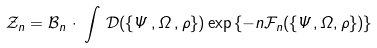<formula> <loc_0><loc_0><loc_500><loc_500>\mathcal { Z } _ { n } = \mathcal { B } _ { n } \, \cdot \, \int \, \mathcal { D } ( \{ \Psi \, , \Omega \, , \rho \} ) \exp \left \{ - n \mathcal { F } _ { n } ( \{ \Psi , \Omega , \rho \} ) \right \}</formula> 